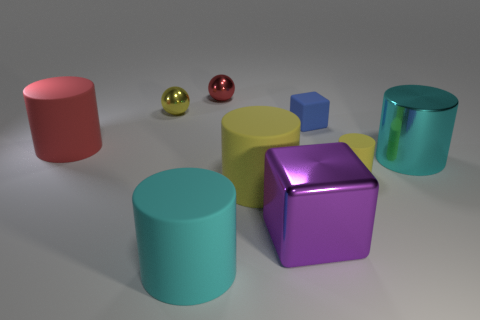There is a sphere that is the same color as the small cylinder; what is its material?
Give a very brief answer. Metal. What number of yellow things have the same shape as the red metallic object?
Ensure brevity in your answer.  1. Does the small block have the same color as the big metal cylinder?
Provide a succinct answer. No. What material is the cyan object behind the big cyan cylinder that is in front of the large cyan metal cylinder that is behind the shiny block?
Your response must be concise. Metal. Are there any big red rubber objects to the left of the red cylinder?
Offer a terse response. No. The cyan object that is the same size as the cyan matte cylinder is what shape?
Provide a short and direct response. Cylinder. Do the large block and the tiny blue thing have the same material?
Provide a succinct answer. No. How many metallic objects are brown cylinders or yellow objects?
Make the answer very short. 1. What is the shape of the tiny thing that is the same color as the small cylinder?
Your answer should be very brief. Sphere. There is a matte object to the right of the blue block; does it have the same color as the tiny rubber block?
Offer a very short reply. No. 